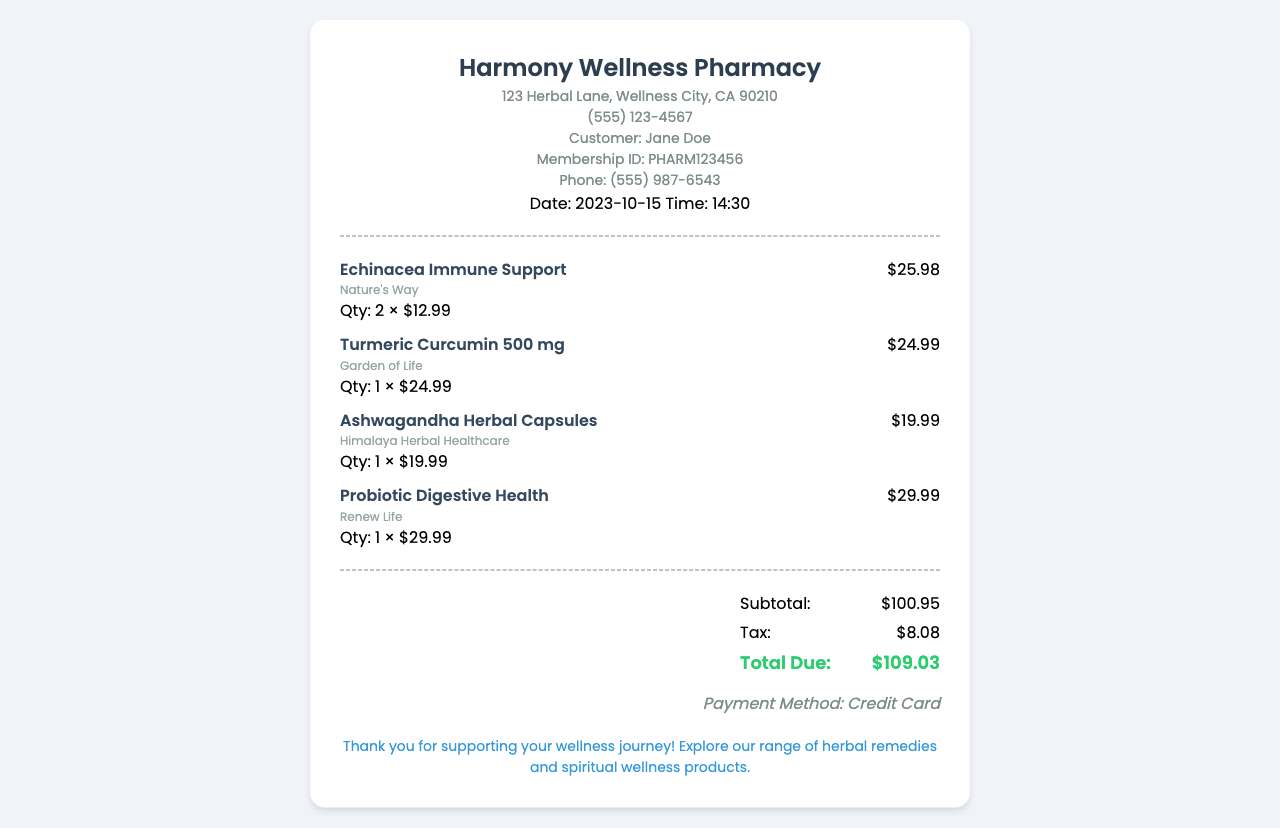What is the name of the pharmacy? The name of the pharmacy is displayed at the top of the receipt.
Answer: Harmony Wellness Pharmacy Who is the customer? The customer name is mentioned under customer info.
Answer: Jane Doe What is the date of the purchase? The date of the purchase can be found in the header section.
Answer: 2023-10-15 How many Echinacea Immune Support products were purchased? The quantity of Echinacea Immune Support is specified next to the product name.
Answer: 2 What is the total due amount? The total amount due is found in the totals section at the end of the receipt.
Answer: $109.03 What was the payment method used? The payment method is mentioned in the totals section of the receipt.
Answer: Credit Card What is the subtotal before tax? The subtotal is indicated just before the tax amount in the totals.
Answer: $100.95 Which product has the highest price? The highest price product is identified by comparing the item prices listed.
Answer: Probiotic Digestive Health What is the tax amount on the purchase? The tax amount is specified in the totals section of the receipt.
Answer: $8.08 